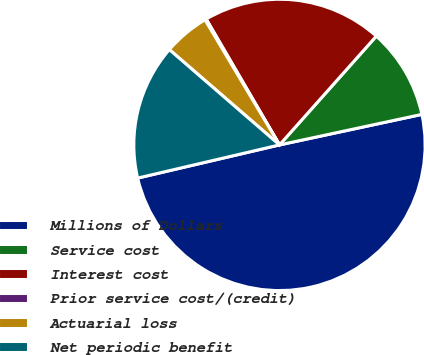Convert chart. <chart><loc_0><loc_0><loc_500><loc_500><pie_chart><fcel>Millions of Dollars<fcel>Service cost<fcel>Interest cost<fcel>Prior service cost/(credit)<fcel>Actuarial loss<fcel>Net periodic benefit<nl><fcel>49.7%<fcel>10.06%<fcel>19.97%<fcel>0.15%<fcel>5.1%<fcel>15.01%<nl></chart> 